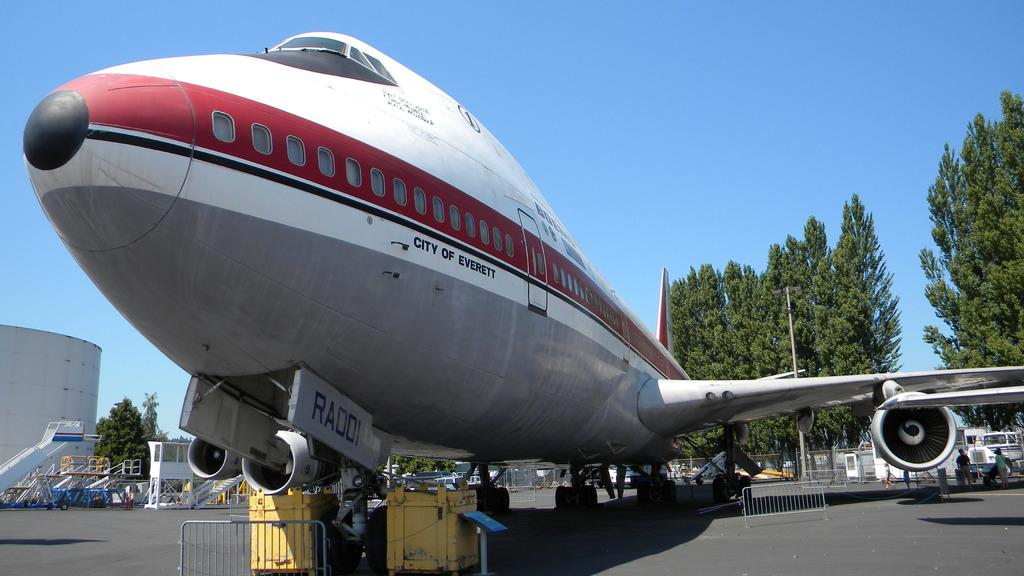Provide a one-sentence caption for the provided image. A front shot of an airplane for the City of Everett. 